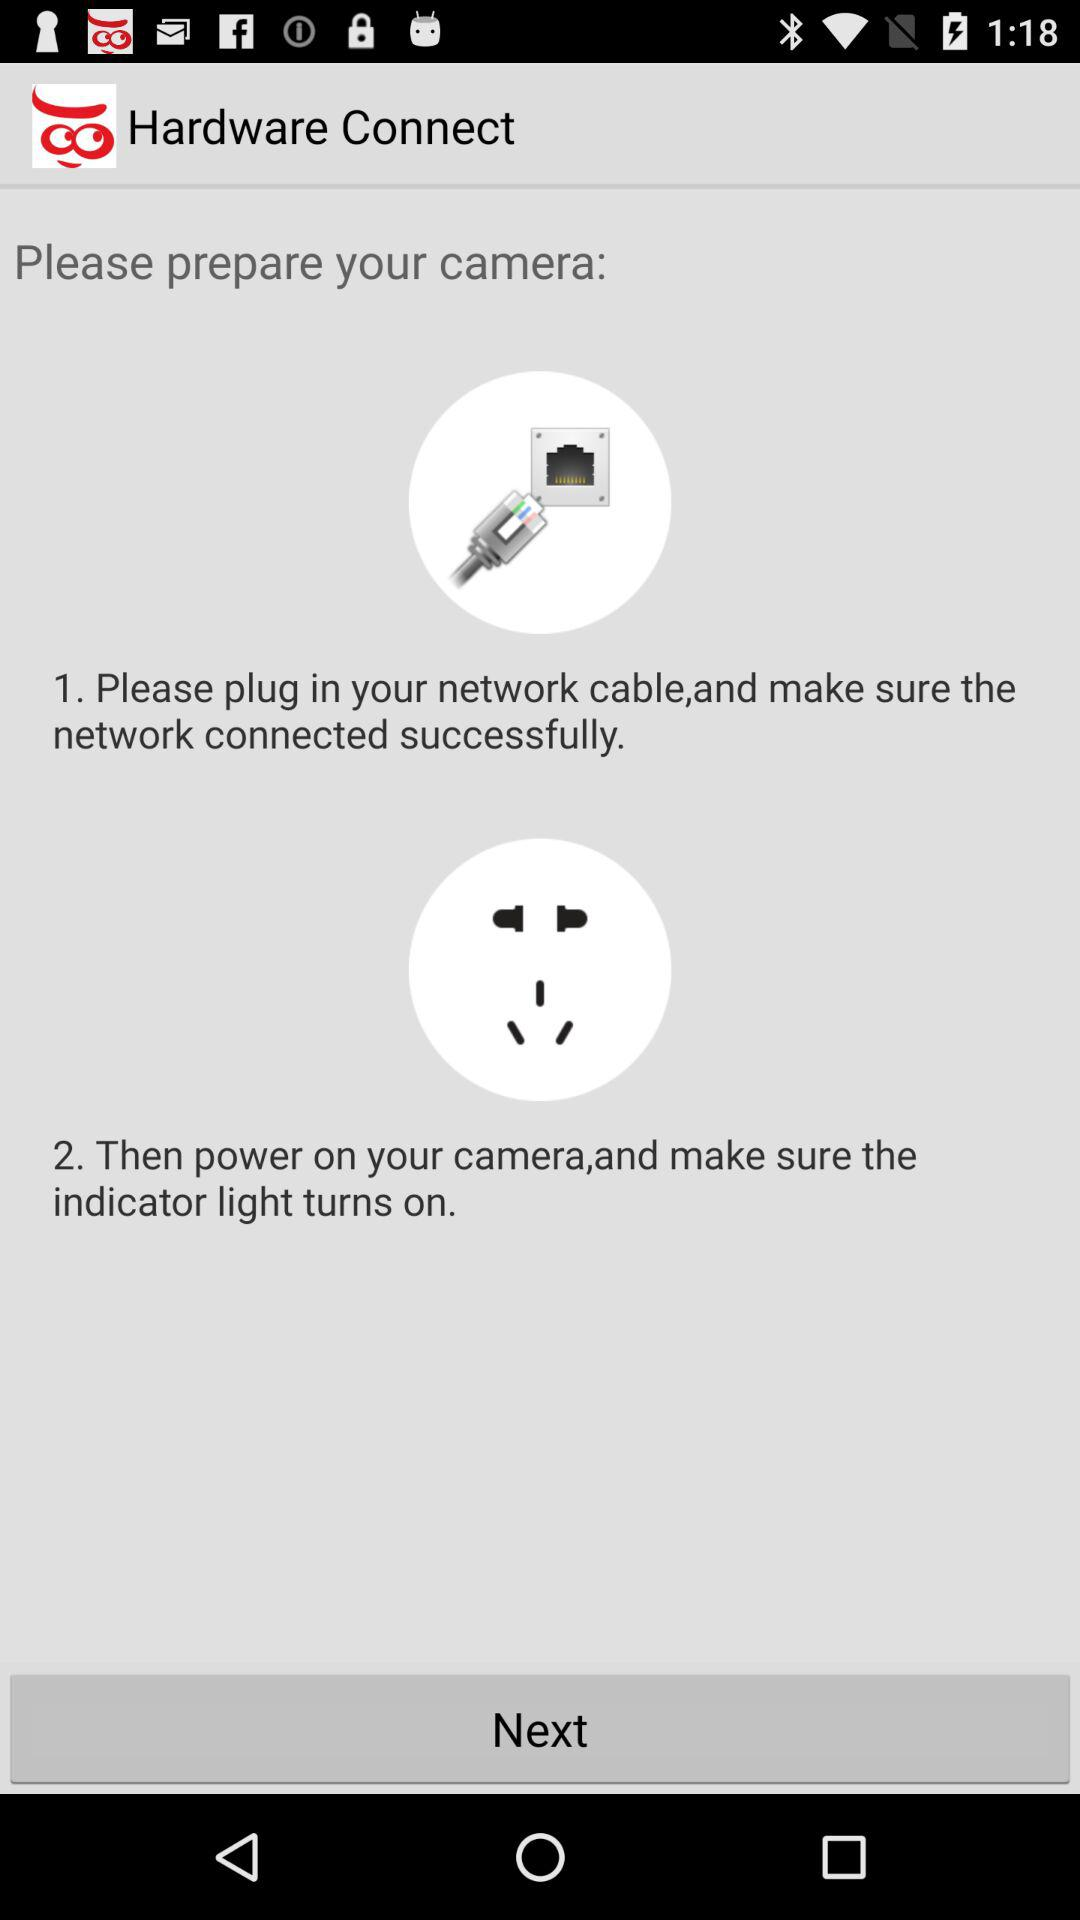What is the second stage in camera preparation? The second stage in camera preparation is to power on the camera and make sure the indicator light turns on. 